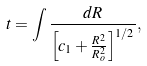Convert formula to latex. <formula><loc_0><loc_0><loc_500><loc_500>t = \int \frac { d R } { \left [ c _ { 1 } + \frac { R ^ { 2 } } { R _ { o } ^ { 2 } } \right ] ^ { 1 / 2 } } ,</formula> 